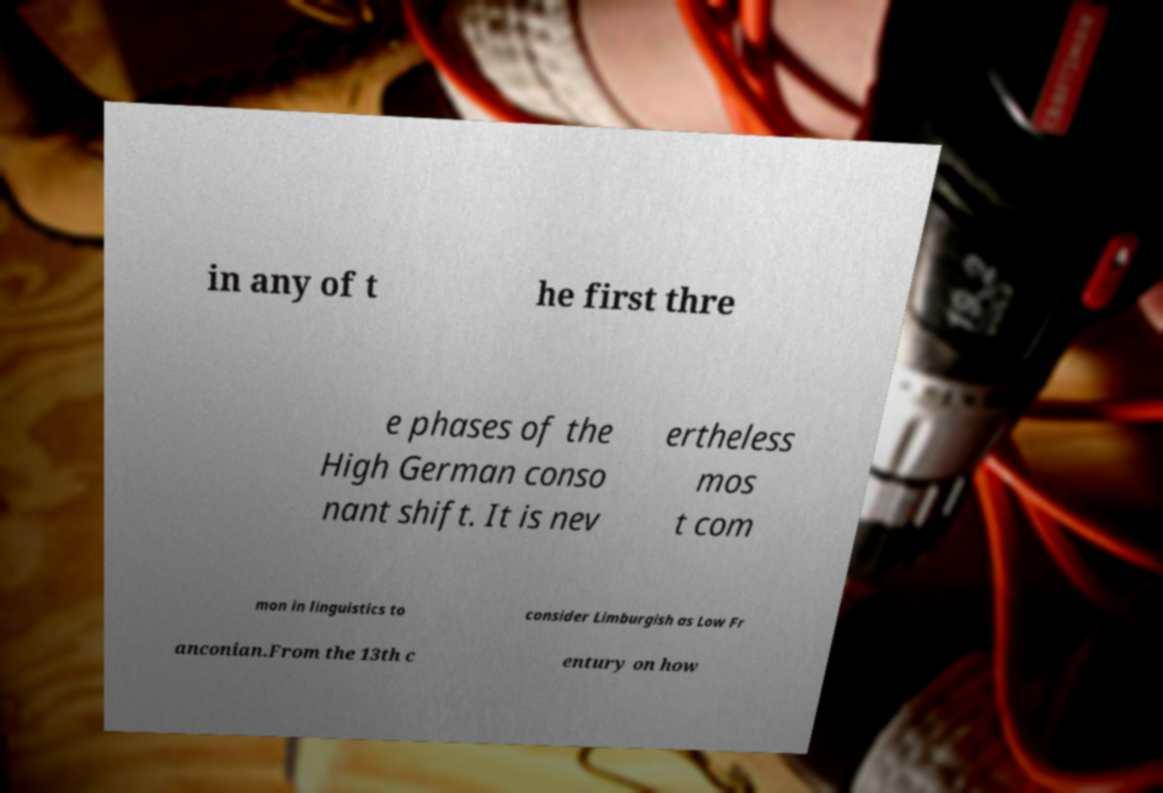What messages or text are displayed in this image? I need them in a readable, typed format. in any of t he first thre e phases of the High German conso nant shift. It is nev ertheless mos t com mon in linguistics to consider Limburgish as Low Fr anconian.From the 13th c entury on how 